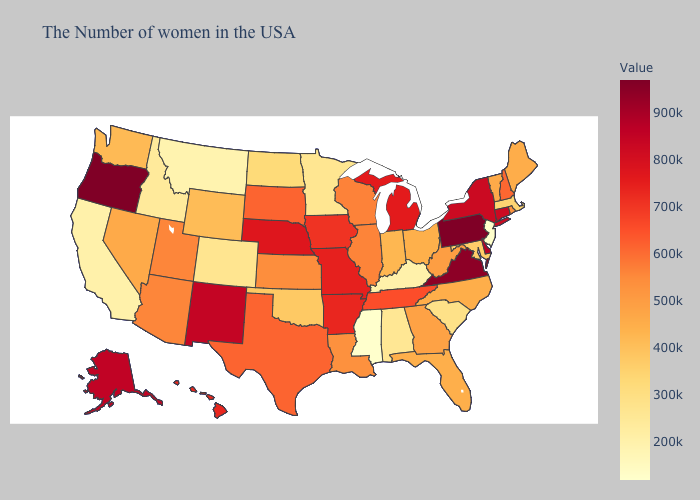Does Missouri have the highest value in the USA?
Answer briefly. No. Which states have the lowest value in the West?
Be succinct. Montana. Does Oregon have the highest value in the USA?
Be succinct. Yes. Which states have the lowest value in the USA?
Answer briefly. New Jersey, Mississippi. Which states hav the highest value in the MidWest?
Keep it brief. Nebraska. 